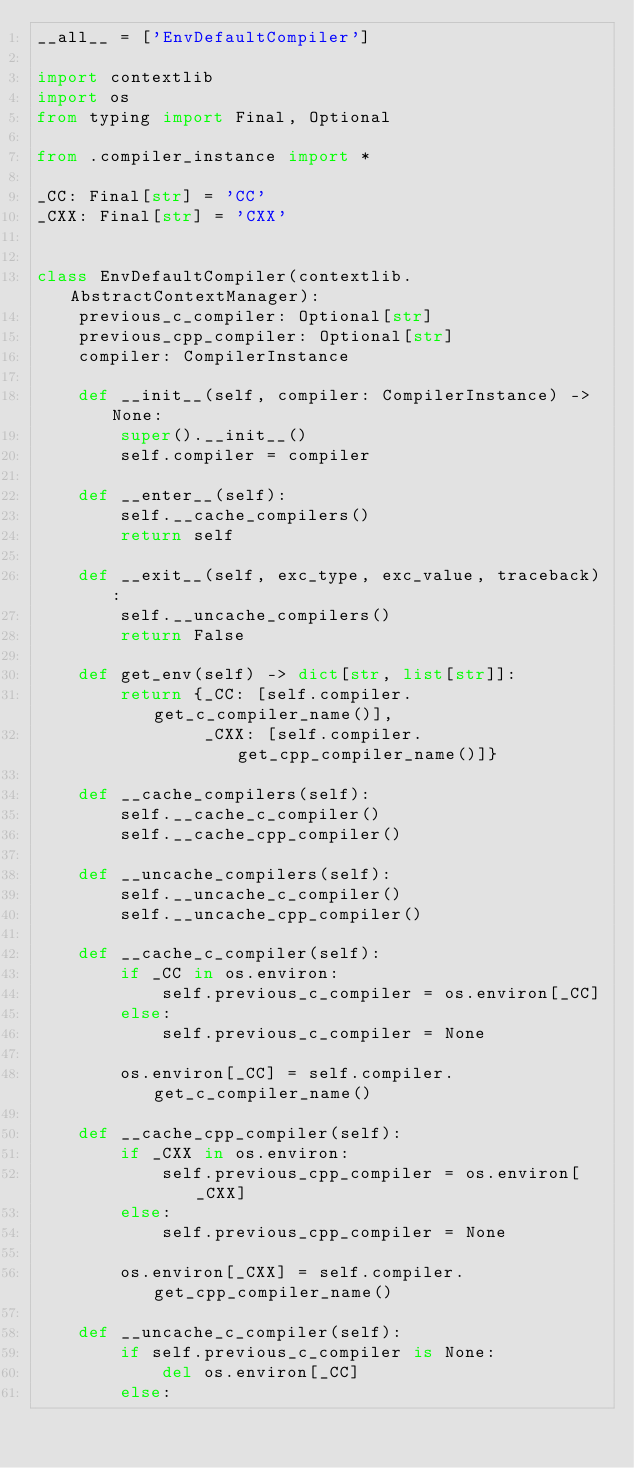<code> <loc_0><loc_0><loc_500><loc_500><_Python_>__all__ = ['EnvDefaultCompiler']

import contextlib
import os
from typing import Final, Optional

from .compiler_instance import *

_CC: Final[str] = 'CC'
_CXX: Final[str] = 'CXX'


class EnvDefaultCompiler(contextlib.AbstractContextManager):
    previous_c_compiler: Optional[str]
    previous_cpp_compiler: Optional[str]
    compiler: CompilerInstance

    def __init__(self, compiler: CompilerInstance) -> None:
        super().__init__()
        self.compiler = compiler

    def __enter__(self):
        self.__cache_compilers()
        return self

    def __exit__(self, exc_type, exc_value, traceback):
        self.__uncache_compilers()
        return False

    def get_env(self) -> dict[str, list[str]]:
        return {_CC: [self.compiler.get_c_compiler_name()],
                _CXX: [self.compiler.get_cpp_compiler_name()]}

    def __cache_compilers(self):
        self.__cache_c_compiler()
        self.__cache_cpp_compiler()

    def __uncache_compilers(self):
        self.__uncache_c_compiler()
        self.__uncache_cpp_compiler()

    def __cache_c_compiler(self):
        if _CC in os.environ:
            self.previous_c_compiler = os.environ[_CC]
        else:
            self.previous_c_compiler = None

        os.environ[_CC] = self.compiler.get_c_compiler_name()

    def __cache_cpp_compiler(self):
        if _CXX in os.environ:
            self.previous_cpp_compiler = os.environ[_CXX]
        else:
            self.previous_cpp_compiler = None

        os.environ[_CXX] = self.compiler.get_cpp_compiler_name()

    def __uncache_c_compiler(self):
        if self.previous_c_compiler is None:
            del os.environ[_CC]
        else:</code> 